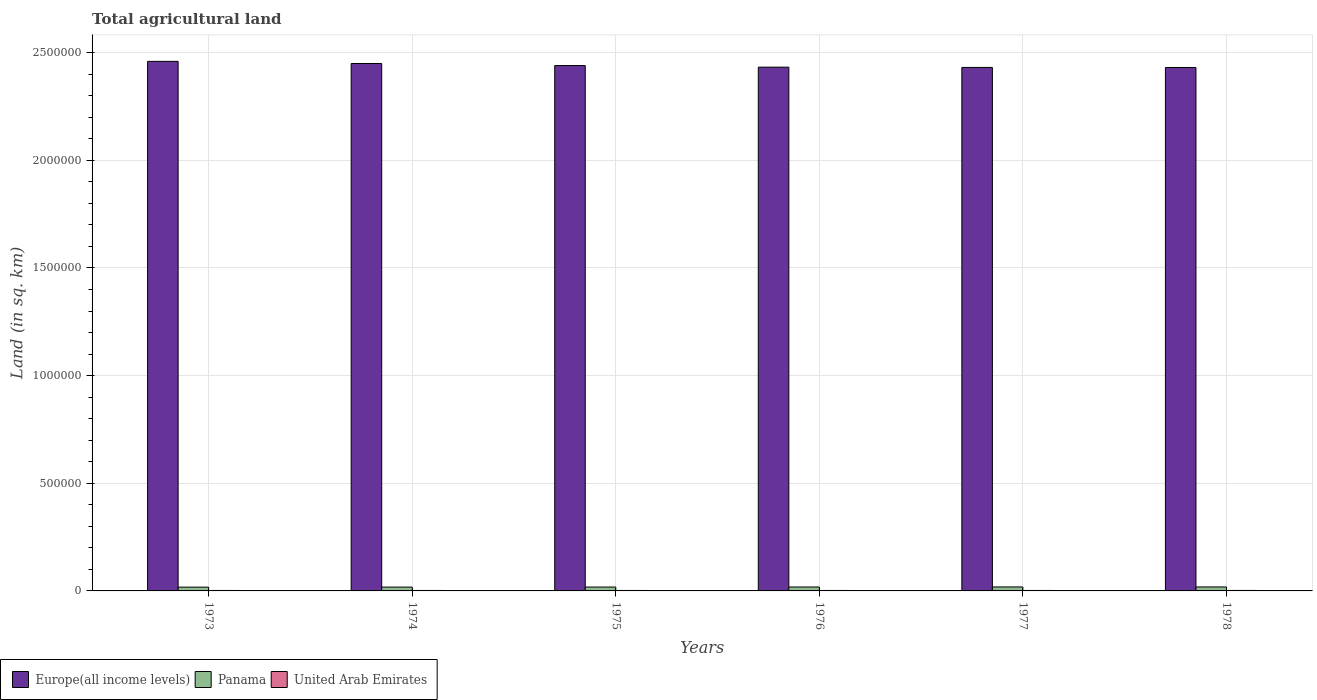How many different coloured bars are there?
Ensure brevity in your answer.  3. Are the number of bars per tick equal to the number of legend labels?
Offer a terse response. Yes. How many bars are there on the 5th tick from the left?
Your response must be concise. 3. What is the label of the 6th group of bars from the left?
Offer a terse response. 1978. What is the total agricultural land in United Arab Emirates in 1976?
Provide a succinct answer. 2160. Across all years, what is the maximum total agricultural land in Europe(all income levels)?
Provide a short and direct response. 2.46e+06. Across all years, what is the minimum total agricultural land in Europe(all income levels)?
Keep it short and to the point. 2.43e+06. In which year was the total agricultural land in Panama maximum?
Offer a terse response. 1978. What is the total total agricultural land in United Arab Emirates in the graph?
Your answer should be very brief. 1.29e+04. What is the difference between the total agricultural land in Panama in 1974 and that in 1976?
Your answer should be compact. -420. What is the difference between the total agricultural land in Europe(all income levels) in 1975 and the total agricultural land in United Arab Emirates in 1976?
Keep it short and to the point. 2.44e+06. What is the average total agricultural land in Panama per year?
Your answer should be compact. 1.81e+04. In the year 1976, what is the difference between the total agricultural land in United Arab Emirates and total agricultural land in Europe(all income levels)?
Provide a short and direct response. -2.43e+06. In how many years, is the total agricultural land in United Arab Emirates greater than 1700000 sq.km?
Give a very brief answer. 0. What is the ratio of the total agricultural land in Europe(all income levels) in 1973 to that in 1978?
Make the answer very short. 1.01. What is the difference between the highest and the second highest total agricultural land in United Arab Emirates?
Keep it short and to the point. 10. What is the difference between the highest and the lowest total agricultural land in Panama?
Offer a very short reply. 870. What does the 3rd bar from the left in 1973 represents?
Provide a succinct answer. United Arab Emirates. What does the 3rd bar from the right in 1975 represents?
Ensure brevity in your answer.  Europe(all income levels). How many bars are there?
Your response must be concise. 18. Are all the bars in the graph horizontal?
Offer a terse response. No. How many years are there in the graph?
Your response must be concise. 6. What is the difference between two consecutive major ticks on the Y-axis?
Your response must be concise. 5.00e+05. Are the values on the major ticks of Y-axis written in scientific E-notation?
Provide a short and direct response. No. Does the graph contain any zero values?
Keep it short and to the point. No. Does the graph contain grids?
Offer a very short reply. Yes. How many legend labels are there?
Give a very brief answer. 3. What is the title of the graph?
Provide a short and direct response. Total agricultural land. What is the label or title of the X-axis?
Give a very brief answer. Years. What is the label or title of the Y-axis?
Provide a short and direct response. Land (in sq. km). What is the Land (in sq. km) of Europe(all income levels) in 1973?
Your answer should be compact. 2.46e+06. What is the Land (in sq. km) of Panama in 1973?
Your response must be concise. 1.76e+04. What is the Land (in sq. km) in United Arab Emirates in 1973?
Give a very brief answer. 2130. What is the Land (in sq. km) of Europe(all income levels) in 1974?
Provide a succinct answer. 2.45e+06. What is the Land (in sq. km) of Panama in 1974?
Your answer should be compact. 1.78e+04. What is the Land (in sq. km) in United Arab Emirates in 1974?
Offer a terse response. 2140. What is the Land (in sq. km) in Europe(all income levels) in 1975?
Provide a short and direct response. 2.44e+06. What is the Land (in sq. km) in Panama in 1975?
Your response must be concise. 1.81e+04. What is the Land (in sq. km) of United Arab Emirates in 1975?
Your answer should be very brief. 2150. What is the Land (in sq. km) of Europe(all income levels) in 1976?
Provide a short and direct response. 2.43e+06. What is the Land (in sq. km) in Panama in 1976?
Offer a terse response. 1.83e+04. What is the Land (in sq. km) of United Arab Emirates in 1976?
Provide a short and direct response. 2160. What is the Land (in sq. km) of Europe(all income levels) in 1977?
Offer a very short reply. 2.43e+06. What is the Land (in sq. km) of Panama in 1977?
Ensure brevity in your answer.  1.85e+04. What is the Land (in sq. km) of United Arab Emirates in 1977?
Your response must be concise. 2170. What is the Land (in sq. km) of Europe(all income levels) in 1978?
Your answer should be very brief. 2.43e+06. What is the Land (in sq. km) of Panama in 1978?
Your answer should be very brief. 1.85e+04. What is the Land (in sq. km) in United Arab Emirates in 1978?
Your answer should be compact. 2180. Across all years, what is the maximum Land (in sq. km) of Europe(all income levels)?
Ensure brevity in your answer.  2.46e+06. Across all years, what is the maximum Land (in sq. km) of Panama?
Keep it short and to the point. 1.85e+04. Across all years, what is the maximum Land (in sq. km) in United Arab Emirates?
Your response must be concise. 2180. Across all years, what is the minimum Land (in sq. km) of Europe(all income levels)?
Ensure brevity in your answer.  2.43e+06. Across all years, what is the minimum Land (in sq. km) in Panama?
Provide a short and direct response. 1.76e+04. Across all years, what is the minimum Land (in sq. km) in United Arab Emirates?
Your answer should be compact. 2130. What is the total Land (in sq. km) in Europe(all income levels) in the graph?
Make the answer very short. 1.46e+07. What is the total Land (in sq. km) of Panama in the graph?
Give a very brief answer. 1.09e+05. What is the total Land (in sq. km) in United Arab Emirates in the graph?
Make the answer very short. 1.29e+04. What is the difference between the Land (in sq. km) in Europe(all income levels) in 1973 and that in 1974?
Give a very brief answer. 9927. What is the difference between the Land (in sq. km) of Panama in 1973 and that in 1974?
Offer a very short reply. -220. What is the difference between the Land (in sq. km) in Europe(all income levels) in 1973 and that in 1975?
Offer a very short reply. 1.95e+04. What is the difference between the Land (in sq. km) of Panama in 1973 and that in 1975?
Keep it short and to the point. -430. What is the difference between the Land (in sq. km) of United Arab Emirates in 1973 and that in 1975?
Your answer should be compact. -20. What is the difference between the Land (in sq. km) of Europe(all income levels) in 1973 and that in 1976?
Your answer should be very brief. 2.70e+04. What is the difference between the Land (in sq. km) of Panama in 1973 and that in 1976?
Provide a short and direct response. -640. What is the difference between the Land (in sq. km) in Europe(all income levels) in 1973 and that in 1977?
Offer a terse response. 2.82e+04. What is the difference between the Land (in sq. km) of Panama in 1973 and that in 1977?
Offer a very short reply. -860. What is the difference between the Land (in sq. km) in United Arab Emirates in 1973 and that in 1977?
Your answer should be compact. -40. What is the difference between the Land (in sq. km) in Europe(all income levels) in 1973 and that in 1978?
Ensure brevity in your answer.  2.85e+04. What is the difference between the Land (in sq. km) in Panama in 1973 and that in 1978?
Ensure brevity in your answer.  -870. What is the difference between the Land (in sq. km) in Europe(all income levels) in 1974 and that in 1975?
Your answer should be very brief. 9586. What is the difference between the Land (in sq. km) in Panama in 1974 and that in 1975?
Offer a very short reply. -210. What is the difference between the Land (in sq. km) in United Arab Emirates in 1974 and that in 1975?
Offer a terse response. -10. What is the difference between the Land (in sq. km) in Europe(all income levels) in 1974 and that in 1976?
Provide a succinct answer. 1.71e+04. What is the difference between the Land (in sq. km) in Panama in 1974 and that in 1976?
Give a very brief answer. -420. What is the difference between the Land (in sq. km) of United Arab Emirates in 1974 and that in 1976?
Your answer should be very brief. -20. What is the difference between the Land (in sq. km) of Europe(all income levels) in 1974 and that in 1977?
Provide a short and direct response. 1.83e+04. What is the difference between the Land (in sq. km) in Panama in 1974 and that in 1977?
Keep it short and to the point. -640. What is the difference between the Land (in sq. km) of United Arab Emirates in 1974 and that in 1977?
Your response must be concise. -30. What is the difference between the Land (in sq. km) of Europe(all income levels) in 1974 and that in 1978?
Your answer should be compact. 1.86e+04. What is the difference between the Land (in sq. km) of Panama in 1974 and that in 1978?
Keep it short and to the point. -650. What is the difference between the Land (in sq. km) of Europe(all income levels) in 1975 and that in 1976?
Ensure brevity in your answer.  7469. What is the difference between the Land (in sq. km) in Panama in 1975 and that in 1976?
Offer a very short reply. -210. What is the difference between the Land (in sq. km) of Europe(all income levels) in 1975 and that in 1977?
Provide a short and direct response. 8730. What is the difference between the Land (in sq. km) in Panama in 1975 and that in 1977?
Ensure brevity in your answer.  -430. What is the difference between the Land (in sq. km) of United Arab Emirates in 1975 and that in 1977?
Give a very brief answer. -20. What is the difference between the Land (in sq. km) of Europe(all income levels) in 1975 and that in 1978?
Your response must be concise. 8982. What is the difference between the Land (in sq. km) in Panama in 1975 and that in 1978?
Ensure brevity in your answer.  -440. What is the difference between the Land (in sq. km) in Europe(all income levels) in 1976 and that in 1977?
Your answer should be compact. 1261. What is the difference between the Land (in sq. km) in Panama in 1976 and that in 1977?
Ensure brevity in your answer.  -220. What is the difference between the Land (in sq. km) of United Arab Emirates in 1976 and that in 1977?
Keep it short and to the point. -10. What is the difference between the Land (in sq. km) in Europe(all income levels) in 1976 and that in 1978?
Offer a terse response. 1513. What is the difference between the Land (in sq. km) of Panama in 1976 and that in 1978?
Ensure brevity in your answer.  -230. What is the difference between the Land (in sq. km) in Europe(all income levels) in 1977 and that in 1978?
Keep it short and to the point. 252. What is the difference between the Land (in sq. km) in Panama in 1977 and that in 1978?
Your answer should be compact. -10. What is the difference between the Land (in sq. km) in United Arab Emirates in 1977 and that in 1978?
Make the answer very short. -10. What is the difference between the Land (in sq. km) in Europe(all income levels) in 1973 and the Land (in sq. km) in Panama in 1974?
Give a very brief answer. 2.44e+06. What is the difference between the Land (in sq. km) of Europe(all income levels) in 1973 and the Land (in sq. km) of United Arab Emirates in 1974?
Keep it short and to the point. 2.46e+06. What is the difference between the Land (in sq. km) of Panama in 1973 and the Land (in sq. km) of United Arab Emirates in 1974?
Give a very brief answer. 1.55e+04. What is the difference between the Land (in sq. km) in Europe(all income levels) in 1973 and the Land (in sq. km) in Panama in 1975?
Your answer should be very brief. 2.44e+06. What is the difference between the Land (in sq. km) in Europe(all income levels) in 1973 and the Land (in sq. km) in United Arab Emirates in 1975?
Give a very brief answer. 2.46e+06. What is the difference between the Land (in sq. km) of Panama in 1973 and the Land (in sq. km) of United Arab Emirates in 1975?
Provide a succinct answer. 1.55e+04. What is the difference between the Land (in sq. km) of Europe(all income levels) in 1973 and the Land (in sq. km) of Panama in 1976?
Your answer should be very brief. 2.44e+06. What is the difference between the Land (in sq. km) of Europe(all income levels) in 1973 and the Land (in sq. km) of United Arab Emirates in 1976?
Make the answer very short. 2.46e+06. What is the difference between the Land (in sq. km) in Panama in 1973 and the Land (in sq. km) in United Arab Emirates in 1976?
Your answer should be very brief. 1.55e+04. What is the difference between the Land (in sq. km) of Europe(all income levels) in 1973 and the Land (in sq. km) of Panama in 1977?
Provide a succinct answer. 2.44e+06. What is the difference between the Land (in sq. km) of Europe(all income levels) in 1973 and the Land (in sq. km) of United Arab Emirates in 1977?
Offer a terse response. 2.46e+06. What is the difference between the Land (in sq. km) in Panama in 1973 and the Land (in sq. km) in United Arab Emirates in 1977?
Give a very brief answer. 1.55e+04. What is the difference between the Land (in sq. km) of Europe(all income levels) in 1973 and the Land (in sq. km) of Panama in 1978?
Provide a succinct answer. 2.44e+06. What is the difference between the Land (in sq. km) of Europe(all income levels) in 1973 and the Land (in sq. km) of United Arab Emirates in 1978?
Keep it short and to the point. 2.46e+06. What is the difference between the Land (in sq. km) of Panama in 1973 and the Land (in sq. km) of United Arab Emirates in 1978?
Your response must be concise. 1.54e+04. What is the difference between the Land (in sq. km) in Europe(all income levels) in 1974 and the Land (in sq. km) in Panama in 1975?
Offer a terse response. 2.43e+06. What is the difference between the Land (in sq. km) in Europe(all income levels) in 1974 and the Land (in sq. km) in United Arab Emirates in 1975?
Offer a terse response. 2.45e+06. What is the difference between the Land (in sq. km) in Panama in 1974 and the Land (in sq. km) in United Arab Emirates in 1975?
Offer a very short reply. 1.57e+04. What is the difference between the Land (in sq. km) in Europe(all income levels) in 1974 and the Land (in sq. km) in Panama in 1976?
Your response must be concise. 2.43e+06. What is the difference between the Land (in sq. km) of Europe(all income levels) in 1974 and the Land (in sq. km) of United Arab Emirates in 1976?
Your answer should be compact. 2.45e+06. What is the difference between the Land (in sq. km) of Panama in 1974 and the Land (in sq. km) of United Arab Emirates in 1976?
Provide a succinct answer. 1.57e+04. What is the difference between the Land (in sq. km) of Europe(all income levels) in 1974 and the Land (in sq. km) of Panama in 1977?
Your response must be concise. 2.43e+06. What is the difference between the Land (in sq. km) in Europe(all income levels) in 1974 and the Land (in sq. km) in United Arab Emirates in 1977?
Ensure brevity in your answer.  2.45e+06. What is the difference between the Land (in sq. km) in Panama in 1974 and the Land (in sq. km) in United Arab Emirates in 1977?
Your response must be concise. 1.57e+04. What is the difference between the Land (in sq. km) of Europe(all income levels) in 1974 and the Land (in sq. km) of Panama in 1978?
Offer a very short reply. 2.43e+06. What is the difference between the Land (in sq. km) of Europe(all income levels) in 1974 and the Land (in sq. km) of United Arab Emirates in 1978?
Offer a very short reply. 2.45e+06. What is the difference between the Land (in sq. km) in Panama in 1974 and the Land (in sq. km) in United Arab Emirates in 1978?
Your answer should be very brief. 1.57e+04. What is the difference between the Land (in sq. km) in Europe(all income levels) in 1975 and the Land (in sq. km) in Panama in 1976?
Your answer should be very brief. 2.42e+06. What is the difference between the Land (in sq. km) in Europe(all income levels) in 1975 and the Land (in sq. km) in United Arab Emirates in 1976?
Give a very brief answer. 2.44e+06. What is the difference between the Land (in sq. km) in Panama in 1975 and the Land (in sq. km) in United Arab Emirates in 1976?
Make the answer very short. 1.59e+04. What is the difference between the Land (in sq. km) of Europe(all income levels) in 1975 and the Land (in sq. km) of Panama in 1977?
Provide a short and direct response. 2.42e+06. What is the difference between the Land (in sq. km) in Europe(all income levels) in 1975 and the Land (in sq. km) in United Arab Emirates in 1977?
Your response must be concise. 2.44e+06. What is the difference between the Land (in sq. km) in Panama in 1975 and the Land (in sq. km) in United Arab Emirates in 1977?
Your answer should be very brief. 1.59e+04. What is the difference between the Land (in sq. km) in Europe(all income levels) in 1975 and the Land (in sq. km) in Panama in 1978?
Ensure brevity in your answer.  2.42e+06. What is the difference between the Land (in sq. km) in Europe(all income levels) in 1975 and the Land (in sq. km) in United Arab Emirates in 1978?
Keep it short and to the point. 2.44e+06. What is the difference between the Land (in sq. km) of Panama in 1975 and the Land (in sq. km) of United Arab Emirates in 1978?
Offer a terse response. 1.59e+04. What is the difference between the Land (in sq. km) in Europe(all income levels) in 1976 and the Land (in sq. km) in Panama in 1977?
Your response must be concise. 2.41e+06. What is the difference between the Land (in sq. km) in Europe(all income levels) in 1976 and the Land (in sq. km) in United Arab Emirates in 1977?
Ensure brevity in your answer.  2.43e+06. What is the difference between the Land (in sq. km) in Panama in 1976 and the Land (in sq. km) in United Arab Emirates in 1977?
Provide a short and direct response. 1.61e+04. What is the difference between the Land (in sq. km) of Europe(all income levels) in 1976 and the Land (in sq. km) of Panama in 1978?
Keep it short and to the point. 2.41e+06. What is the difference between the Land (in sq. km) in Europe(all income levels) in 1976 and the Land (in sq. km) in United Arab Emirates in 1978?
Make the answer very short. 2.43e+06. What is the difference between the Land (in sq. km) in Panama in 1976 and the Land (in sq. km) in United Arab Emirates in 1978?
Provide a short and direct response. 1.61e+04. What is the difference between the Land (in sq. km) in Europe(all income levels) in 1977 and the Land (in sq. km) in Panama in 1978?
Your response must be concise. 2.41e+06. What is the difference between the Land (in sq. km) of Europe(all income levels) in 1977 and the Land (in sq. km) of United Arab Emirates in 1978?
Provide a succinct answer. 2.43e+06. What is the difference between the Land (in sq. km) of Panama in 1977 and the Land (in sq. km) of United Arab Emirates in 1978?
Offer a very short reply. 1.63e+04. What is the average Land (in sq. km) of Europe(all income levels) per year?
Ensure brevity in your answer.  2.44e+06. What is the average Land (in sq. km) of Panama per year?
Your response must be concise. 1.81e+04. What is the average Land (in sq. km) of United Arab Emirates per year?
Provide a short and direct response. 2155. In the year 1973, what is the difference between the Land (in sq. km) in Europe(all income levels) and Land (in sq. km) in Panama?
Your response must be concise. 2.44e+06. In the year 1973, what is the difference between the Land (in sq. km) in Europe(all income levels) and Land (in sq. km) in United Arab Emirates?
Your answer should be very brief. 2.46e+06. In the year 1973, what is the difference between the Land (in sq. km) in Panama and Land (in sq. km) in United Arab Emirates?
Offer a terse response. 1.55e+04. In the year 1974, what is the difference between the Land (in sq. km) in Europe(all income levels) and Land (in sq. km) in Panama?
Offer a terse response. 2.43e+06. In the year 1974, what is the difference between the Land (in sq. km) of Europe(all income levels) and Land (in sq. km) of United Arab Emirates?
Offer a terse response. 2.45e+06. In the year 1974, what is the difference between the Land (in sq. km) of Panama and Land (in sq. km) of United Arab Emirates?
Offer a very short reply. 1.57e+04. In the year 1975, what is the difference between the Land (in sq. km) in Europe(all income levels) and Land (in sq. km) in Panama?
Make the answer very short. 2.42e+06. In the year 1975, what is the difference between the Land (in sq. km) of Europe(all income levels) and Land (in sq. km) of United Arab Emirates?
Offer a very short reply. 2.44e+06. In the year 1975, what is the difference between the Land (in sq. km) in Panama and Land (in sq. km) in United Arab Emirates?
Ensure brevity in your answer.  1.59e+04. In the year 1976, what is the difference between the Land (in sq. km) in Europe(all income levels) and Land (in sq. km) in Panama?
Your response must be concise. 2.41e+06. In the year 1976, what is the difference between the Land (in sq. km) in Europe(all income levels) and Land (in sq. km) in United Arab Emirates?
Offer a terse response. 2.43e+06. In the year 1976, what is the difference between the Land (in sq. km) of Panama and Land (in sq. km) of United Arab Emirates?
Provide a succinct answer. 1.61e+04. In the year 1977, what is the difference between the Land (in sq. km) in Europe(all income levels) and Land (in sq. km) in Panama?
Offer a very short reply. 2.41e+06. In the year 1977, what is the difference between the Land (in sq. km) in Europe(all income levels) and Land (in sq. km) in United Arab Emirates?
Your answer should be very brief. 2.43e+06. In the year 1977, what is the difference between the Land (in sq. km) in Panama and Land (in sq. km) in United Arab Emirates?
Offer a terse response. 1.63e+04. In the year 1978, what is the difference between the Land (in sq. km) of Europe(all income levels) and Land (in sq. km) of Panama?
Your response must be concise. 2.41e+06. In the year 1978, what is the difference between the Land (in sq. km) of Europe(all income levels) and Land (in sq. km) of United Arab Emirates?
Offer a terse response. 2.43e+06. In the year 1978, what is the difference between the Land (in sq. km) of Panama and Land (in sq. km) of United Arab Emirates?
Ensure brevity in your answer.  1.63e+04. What is the ratio of the Land (in sq. km) of Europe(all income levels) in 1973 to that in 1974?
Offer a terse response. 1. What is the ratio of the Land (in sq. km) of Panama in 1973 to that in 1974?
Offer a very short reply. 0.99. What is the ratio of the Land (in sq. km) in Europe(all income levels) in 1973 to that in 1975?
Your response must be concise. 1.01. What is the ratio of the Land (in sq. km) in Panama in 1973 to that in 1975?
Keep it short and to the point. 0.98. What is the ratio of the Land (in sq. km) of Europe(all income levels) in 1973 to that in 1976?
Give a very brief answer. 1.01. What is the ratio of the Land (in sq. km) in United Arab Emirates in 1973 to that in 1976?
Give a very brief answer. 0.99. What is the ratio of the Land (in sq. km) in Europe(all income levels) in 1973 to that in 1977?
Ensure brevity in your answer.  1.01. What is the ratio of the Land (in sq. km) in Panama in 1973 to that in 1977?
Make the answer very short. 0.95. What is the ratio of the Land (in sq. km) of United Arab Emirates in 1973 to that in 1977?
Your answer should be very brief. 0.98. What is the ratio of the Land (in sq. km) of Europe(all income levels) in 1973 to that in 1978?
Offer a very short reply. 1.01. What is the ratio of the Land (in sq. km) of Panama in 1973 to that in 1978?
Ensure brevity in your answer.  0.95. What is the ratio of the Land (in sq. km) of United Arab Emirates in 1973 to that in 1978?
Your answer should be compact. 0.98. What is the ratio of the Land (in sq. km) of Panama in 1974 to that in 1975?
Your response must be concise. 0.99. What is the ratio of the Land (in sq. km) of United Arab Emirates in 1974 to that in 1976?
Provide a succinct answer. 0.99. What is the ratio of the Land (in sq. km) in Europe(all income levels) in 1974 to that in 1977?
Provide a short and direct response. 1.01. What is the ratio of the Land (in sq. km) in Panama in 1974 to that in 1977?
Give a very brief answer. 0.97. What is the ratio of the Land (in sq. km) of United Arab Emirates in 1974 to that in 1977?
Provide a short and direct response. 0.99. What is the ratio of the Land (in sq. km) in Europe(all income levels) in 1974 to that in 1978?
Provide a succinct answer. 1.01. What is the ratio of the Land (in sq. km) in Panama in 1974 to that in 1978?
Your answer should be compact. 0.96. What is the ratio of the Land (in sq. km) of United Arab Emirates in 1974 to that in 1978?
Provide a short and direct response. 0.98. What is the ratio of the Land (in sq. km) in United Arab Emirates in 1975 to that in 1976?
Give a very brief answer. 1. What is the ratio of the Land (in sq. km) of Europe(all income levels) in 1975 to that in 1977?
Give a very brief answer. 1. What is the ratio of the Land (in sq. km) in Panama in 1975 to that in 1977?
Ensure brevity in your answer.  0.98. What is the ratio of the Land (in sq. km) in Europe(all income levels) in 1975 to that in 1978?
Make the answer very short. 1. What is the ratio of the Land (in sq. km) in Panama in 1975 to that in 1978?
Provide a short and direct response. 0.98. What is the ratio of the Land (in sq. km) in United Arab Emirates in 1975 to that in 1978?
Make the answer very short. 0.99. What is the ratio of the Land (in sq. km) in Europe(all income levels) in 1976 to that in 1977?
Provide a succinct answer. 1. What is the ratio of the Land (in sq. km) in Panama in 1976 to that in 1977?
Provide a short and direct response. 0.99. What is the ratio of the Land (in sq. km) in Europe(all income levels) in 1976 to that in 1978?
Give a very brief answer. 1. What is the ratio of the Land (in sq. km) in Panama in 1976 to that in 1978?
Make the answer very short. 0.99. What is the ratio of the Land (in sq. km) in Europe(all income levels) in 1977 to that in 1978?
Give a very brief answer. 1. What is the ratio of the Land (in sq. km) in Panama in 1977 to that in 1978?
Provide a succinct answer. 1. What is the ratio of the Land (in sq. km) of United Arab Emirates in 1977 to that in 1978?
Make the answer very short. 1. What is the difference between the highest and the second highest Land (in sq. km) of Europe(all income levels)?
Keep it short and to the point. 9927. What is the difference between the highest and the second highest Land (in sq. km) of Panama?
Ensure brevity in your answer.  10. What is the difference between the highest and the lowest Land (in sq. km) in Europe(all income levels)?
Offer a terse response. 2.85e+04. What is the difference between the highest and the lowest Land (in sq. km) of Panama?
Ensure brevity in your answer.  870. What is the difference between the highest and the lowest Land (in sq. km) in United Arab Emirates?
Provide a short and direct response. 50. 